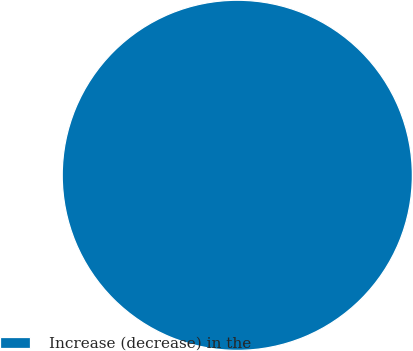<chart> <loc_0><loc_0><loc_500><loc_500><pie_chart><fcel>Increase (decrease) in the<nl><fcel>100.0%<nl></chart> 